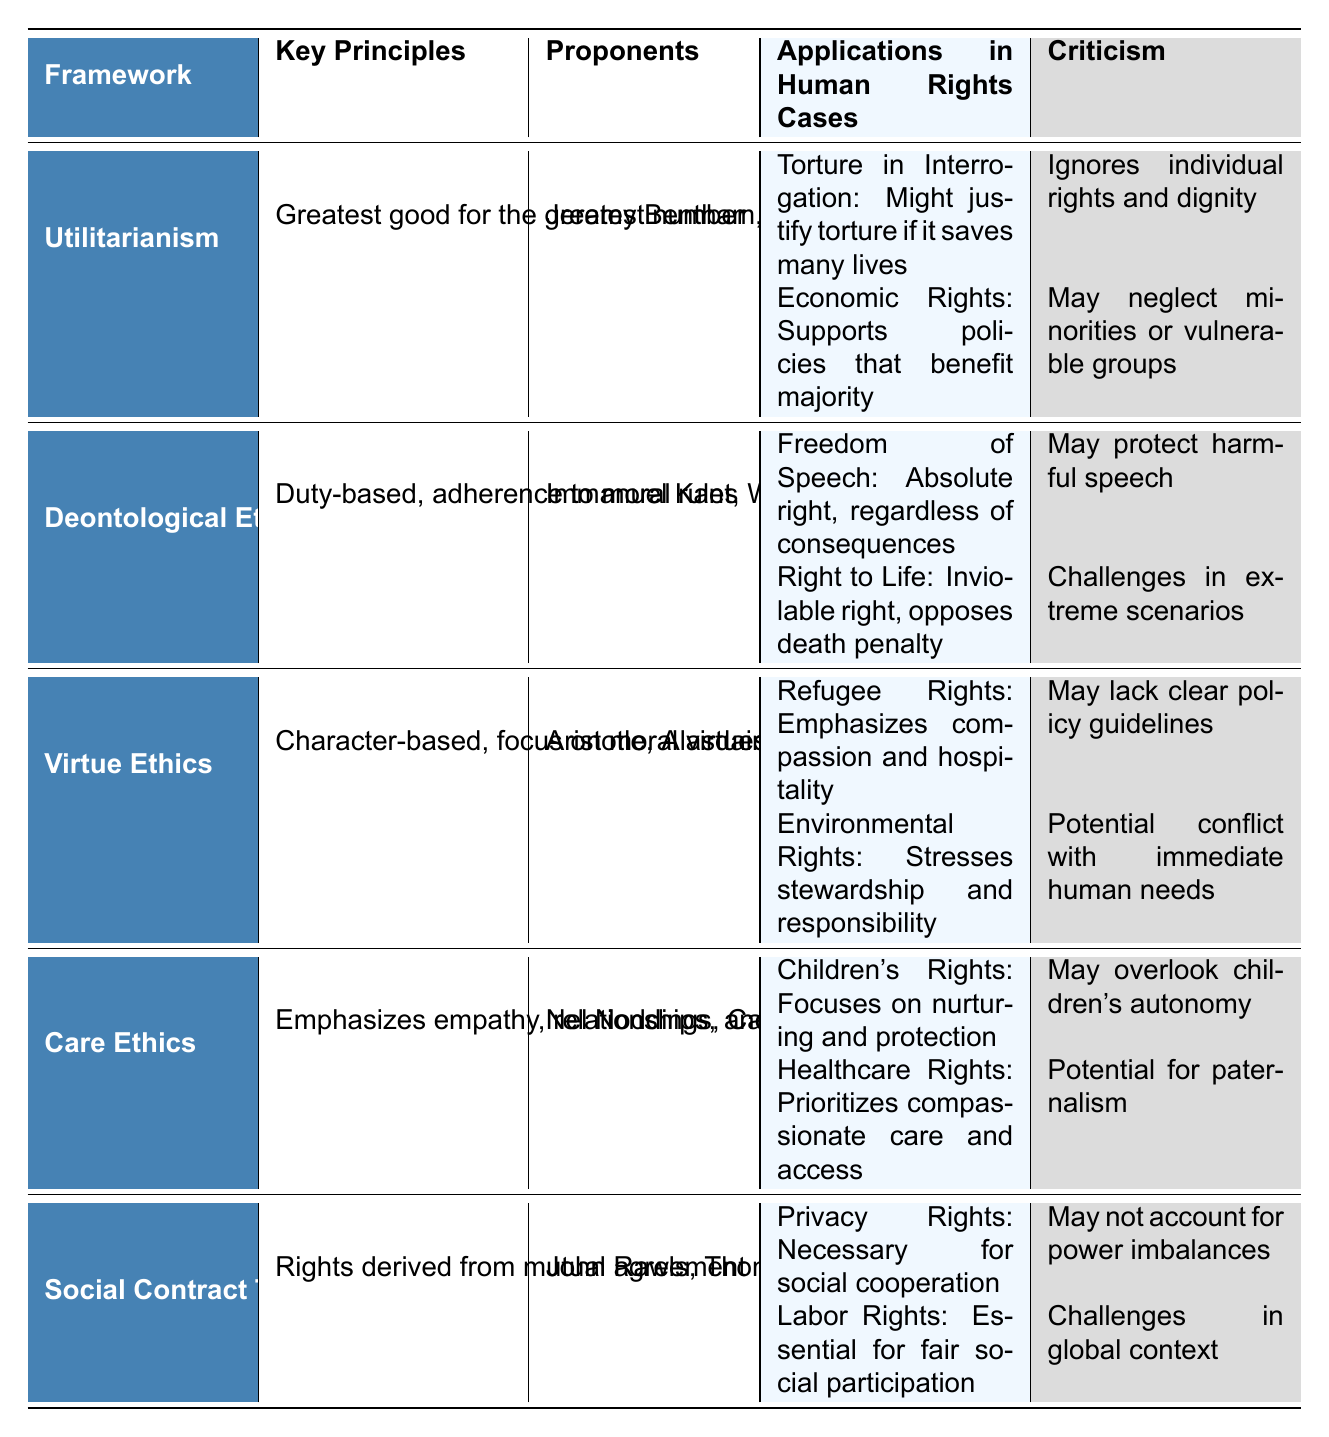What is the key principle of Care Ethics? The table shows that the key principle of Care Ethics is "Emphasizes empathy, relationships, and context." This is directly stated in the "Key Principles" column next to "Care Ethics."
Answer: Emphasizes empathy, relationships, and context Who are the proponents of Deontological Ethics? According to the table, the proponents listed under Deontological Ethics are "Immanuel Kant" and "W.D. Ross." These names are found in the "Proponents" column corresponding to Deontological Ethics.
Answer: Immanuel Kant, W.D. Ross In which human rights case does Utilitarianism face criticism for neglecting vulnerable groups? The case of "Economic Rights" is noted under Utilitarianism. The corresponding criticism states, "May neglect minorities or vulnerable groups." This is found in the "Applications in Human Rights Cases" and "Criticism" columns for Utilitarianism.
Answer: Economic Rights How many applications in human rights cases does Virtue Ethics have listed? The table indicates that Virtue Ethics lists two applications in human rights cases: "Refugee Rights" and "Environmental Rights." Thus, the count of applications is based on the number of entries under that section.
Answer: 2 Is "Right to Life" an application of Utilitarianism? No, "Right to Life" is listed under Deontological Ethics, not Utilitarianism. This fact can be confirmed by checking the respective sections of the table.
Answer: No Which ethical framework argues against the death penalty and why? Deontological Ethics argues against the death penalty because it considers the "Right to Life" an inviolable right. This argument is found in the "Applications in Human Rights Cases" section for Deontological Ethics.
Answer: Deontological Ethics; inviolable right Compare the criticisms of Care Ethics and Utilitarianism regarding their applications in human rights cases. Care Ethics is criticized for potentially overlooking children's autonomy in regards to "Children's Rights," while Utilitarianism is criticized for ignoring individual rights and dignity in the case of "Torture in Interrogation." This requires looking at both frameworks' criticisms in the table.
Answer: Care Ethics may overlook autonomy; Utilitarianism ignores rights Which ethical framework emphasizes stewardship in environmental rights? The framework that emphasizes stewardship in environmental rights is Virtue Ethics, as seen in the "Applications in Human Rights Cases" section related to "Environmental Rights."
Answer: Virtue Ethics What argument does Social Contract Theory present for Labor Rights? Social Contract Theory argues that Labor Rights are "Essential for fair social participation." This is directly stated in the table under the respective application for Social Contract Theory.
Answer: Essential for fair social participation What is the main ethical concern associated with the argument for torture in interrogation under Utilitarianism? The main ethical concern is that it "Ignores individual rights and dignity." This criticism is specifically stated in the table under Utilitarianism's application regarding torture.
Answer: Ignores individual rights and dignity Evaluate the commonalities between Virtue Ethics and Care Ethics in their applications to human rights cases. Both Virtue Ethics and Care Ethics emphasize moral virtues and compassion; however, Virtue Ethics advocates compassion in the context of refugee rights, while Care Ethics focuses on nurturing in children's rights. This requires combining insights from both frameworks' applications in the table.
Answer: Focus on compassion and virtues in applications 